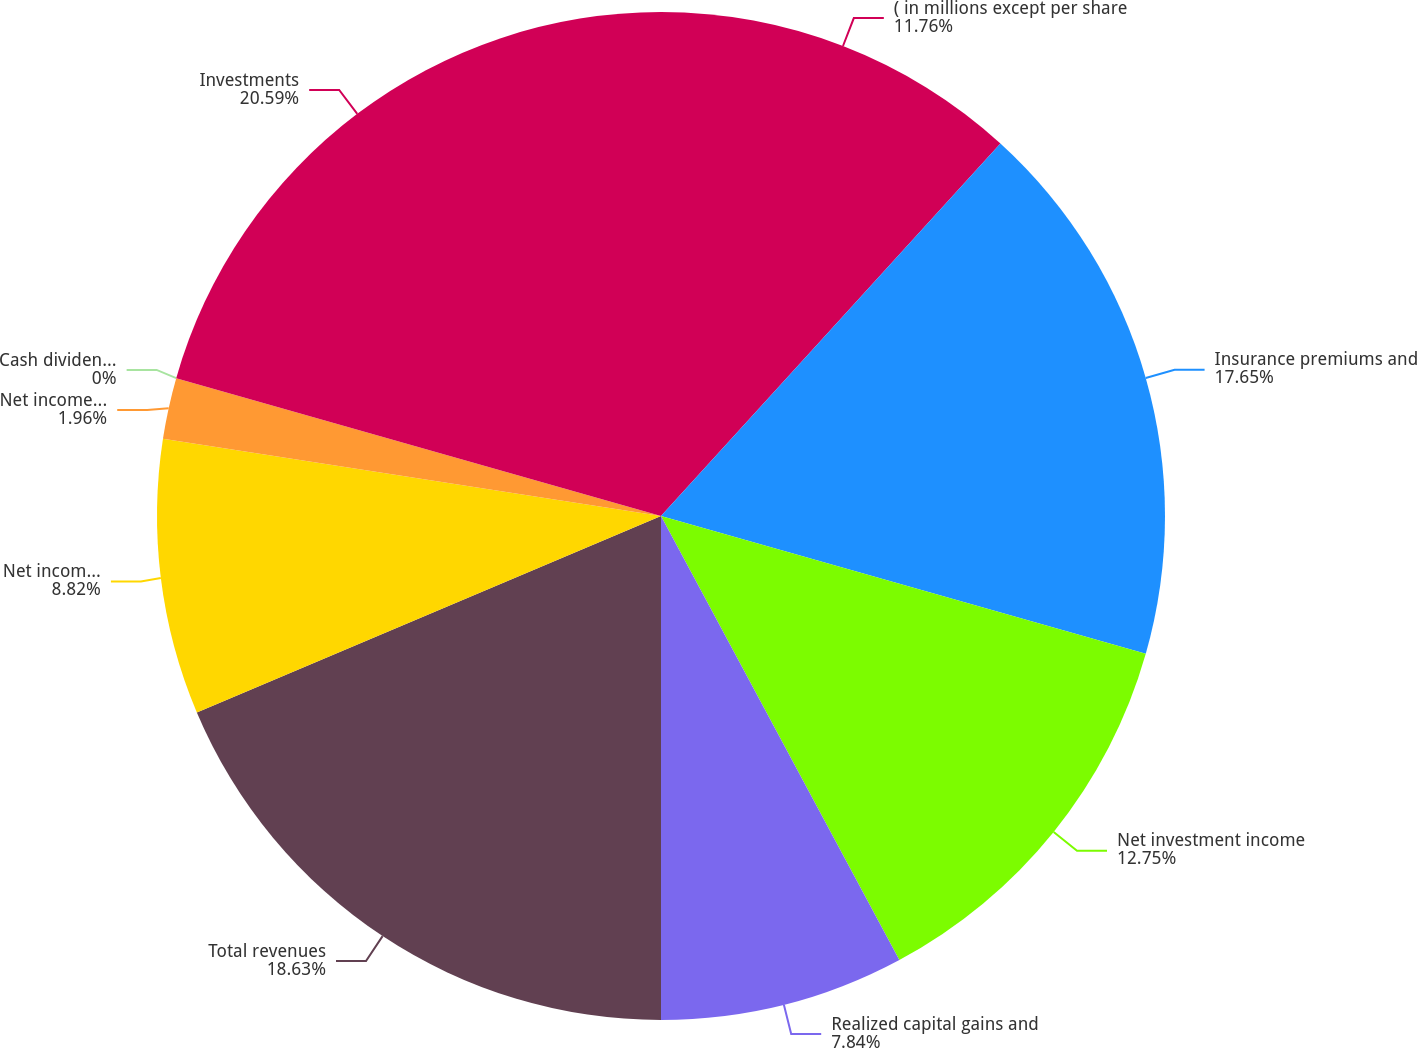Convert chart. <chart><loc_0><loc_0><loc_500><loc_500><pie_chart><fcel>( in millions except per share<fcel>Insurance premiums and<fcel>Net investment income<fcel>Realized capital gains and<fcel>Total revenues<fcel>Net income (loss)<fcel>Net income (loss) per share -<fcel>Cash dividends declared per<fcel>Investments<nl><fcel>11.76%<fcel>17.65%<fcel>12.75%<fcel>7.84%<fcel>18.63%<fcel>8.82%<fcel>1.96%<fcel>0.0%<fcel>20.59%<nl></chart> 